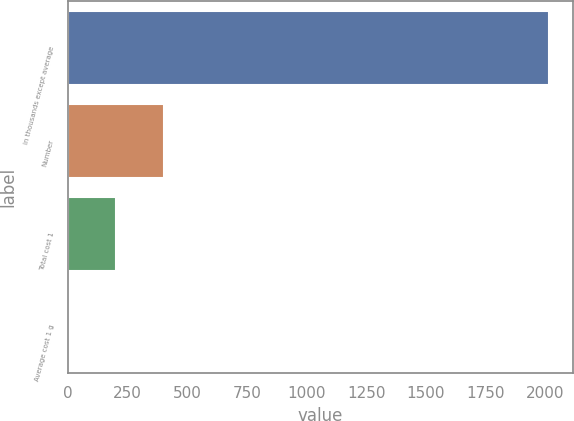Convert chart to OTSL. <chart><loc_0><loc_0><loc_500><loc_500><bar_chart><fcel>in thousands except average<fcel>Number<fcel>Total cost 1<fcel>Average cost 1 g<nl><fcel>2014<fcel>403.92<fcel>202.66<fcel>1.4<nl></chart> 